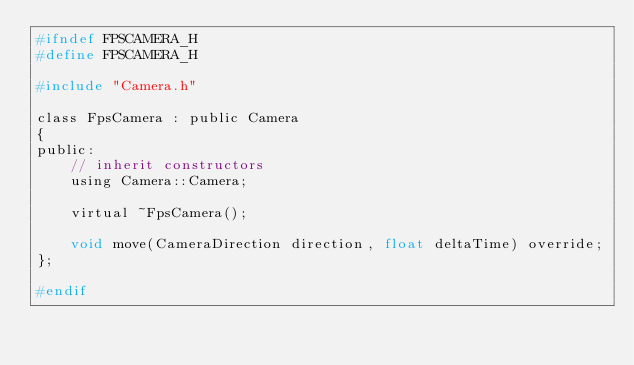<code> <loc_0><loc_0><loc_500><loc_500><_C_>#ifndef FPSCAMERA_H
#define FPSCAMERA_H

#include "Camera.h"

class FpsCamera : public Camera
{
public:
    // inherit constructors
    using Camera::Camera;

    virtual ~FpsCamera();

    void move(CameraDirection direction, float deltaTime) override;
};

#endif</code> 